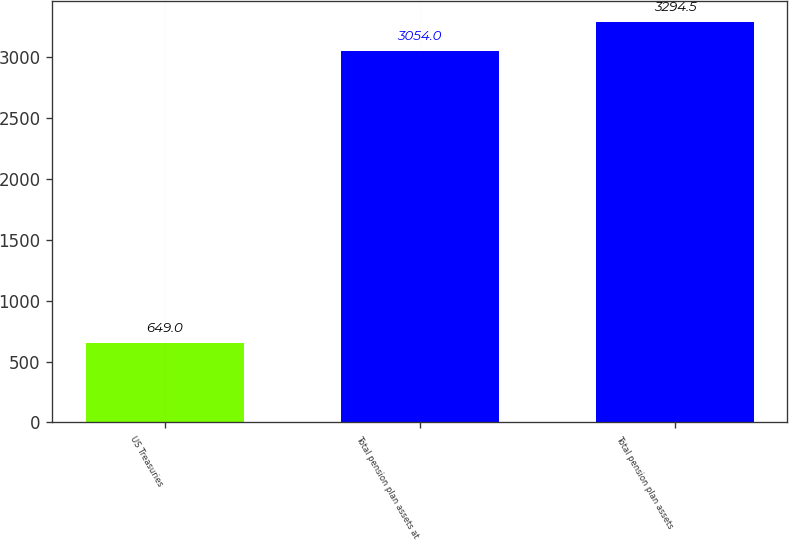Convert chart. <chart><loc_0><loc_0><loc_500><loc_500><bar_chart><fcel>US Treasuries<fcel>Total pension plan assets at<fcel>Total pension plan assets<nl><fcel>649<fcel>3054<fcel>3294.5<nl></chart> 